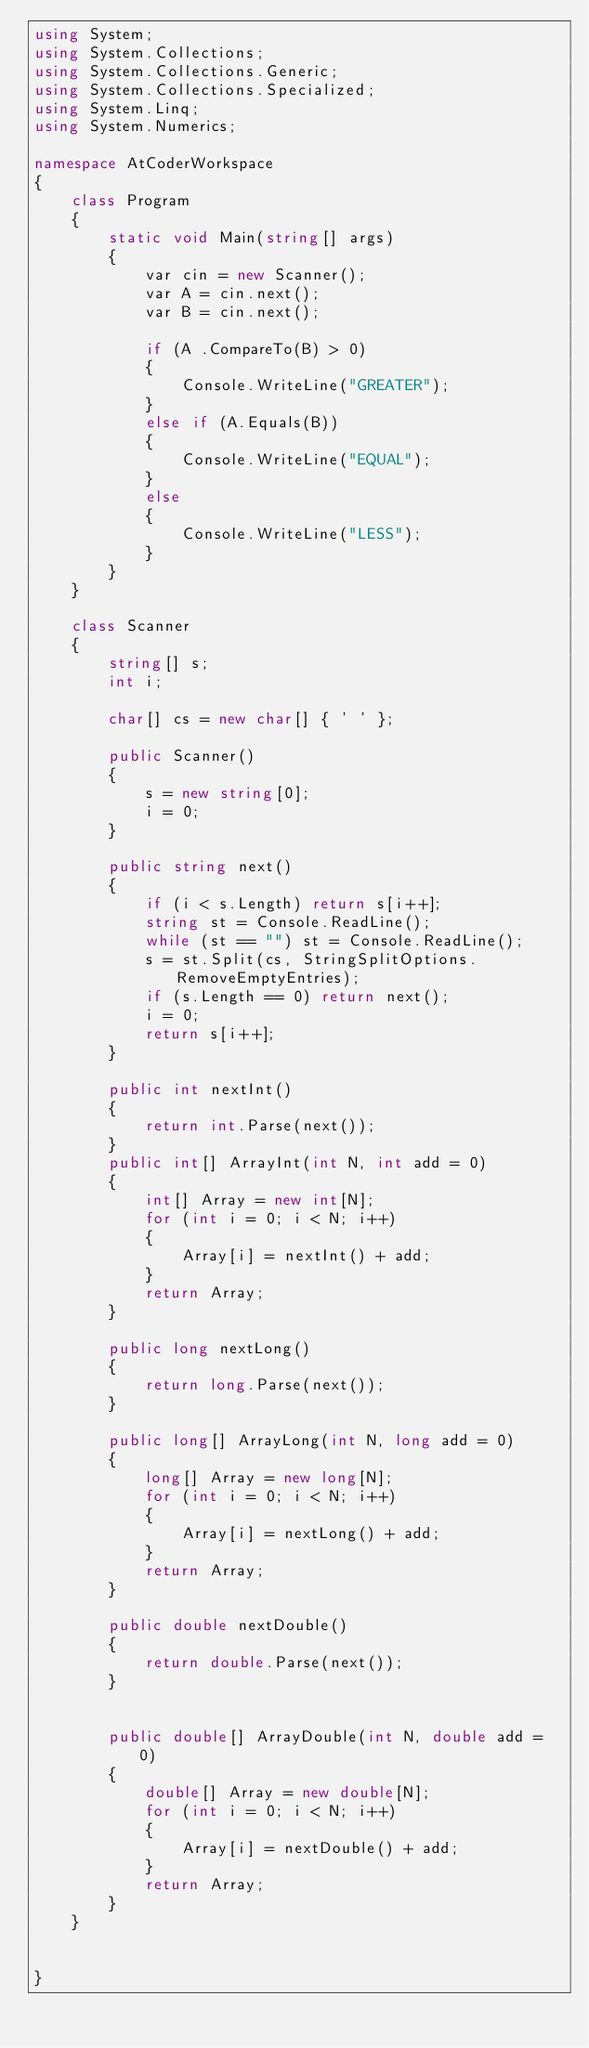Convert code to text. <code><loc_0><loc_0><loc_500><loc_500><_C#_>using System;
using System.Collections;
using System.Collections.Generic;
using System.Collections.Specialized;
using System.Linq;
using System.Numerics;

namespace AtCoderWorkspace
{
    class Program
    {
        static void Main(string[] args)
        {
            var cin = new Scanner();
            var A = cin.next();
            var B = cin.next();

            if (A .CompareTo(B) > 0)
            {
                Console.WriteLine("GREATER");
            }
            else if (A.Equals(B))
            {
                Console.WriteLine("EQUAL"); 
            }
            else
            {
                Console.WriteLine("LESS");
            }            
        }
    }

    class Scanner
    {
        string[] s;
        int i;

        char[] cs = new char[] { ' ' };

        public Scanner()
        {
            s = new string[0];
            i = 0;
        }

        public string next()
        {
            if (i < s.Length) return s[i++];
            string st = Console.ReadLine();
            while (st == "") st = Console.ReadLine();
            s = st.Split(cs, StringSplitOptions.RemoveEmptyEntries);
            if (s.Length == 0) return next();
            i = 0;
            return s[i++];
        }

        public int nextInt()
        {
            return int.Parse(next());
        }
        public int[] ArrayInt(int N, int add = 0)
        {
            int[] Array = new int[N];
            for (int i = 0; i < N; i++)
            {
                Array[i] = nextInt() + add;
            }
            return Array;
        }

        public long nextLong()
        {
            return long.Parse(next());
        }

        public long[] ArrayLong(int N, long add = 0)
        {
            long[] Array = new long[N];
            for (int i = 0; i < N; i++)
            {
                Array[i] = nextLong() + add;
            }
            return Array;
        }

        public double nextDouble()
        {
            return double.Parse(next());
        }


        public double[] ArrayDouble(int N, double add = 0)
        {
            double[] Array = new double[N];
            for (int i = 0; i < N; i++)
            {
                Array[i] = nextDouble() + add;
            }
            return Array;
        }
    }

    
}
</code> 